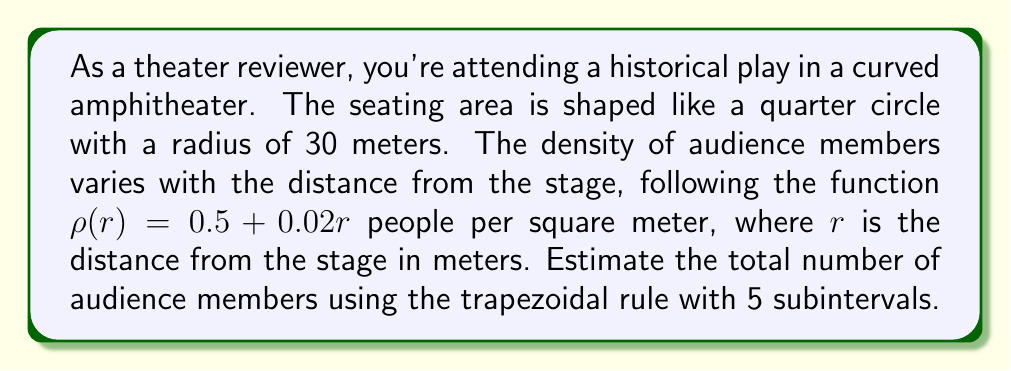Provide a solution to this math problem. To solve this problem, we'll use numerical integration with the trapezoidal rule:

1) The area of a quarter circle is given by $A = \frac{\pi r^2}{4}$. We need to integrate the density function over this area.

2) In polar coordinates, the integral is:

   $$ N = \int_0^{30} \int_0^{\pi/2} \rho(r) \cdot r \, d\theta \, dr $$

3) Integrating with respect to $\theta$:

   $$ N = \frac{\pi}{2} \int_0^{30} (0.5 + 0.02r) \cdot r \, dr $$

4) We'll use the trapezoidal rule with 5 subintervals. The step size is $h = \frac{30}{5} = 6$.

5) The trapezoidal rule formula is:

   $$ \int_a^b f(x) dx \approx \frac{h}{2}[f(x_0) + 2f(x_1) + 2f(x_2) + ... + 2f(x_{n-1}) + f(x_n)] $$

6) We need to evaluate $f(r) = \frac{\pi}{2}(0.5 + 0.02r) \cdot r$ at $r = 0, 6, 12, 18, 24, 30$:

   $f(0) = 0$
   $f(6) = 9.42\pi$
   $f(12) = 37.68\pi$
   $f(18) = 84.78\pi$
   $f(24) = 150.72\pi$
   $f(30) = 235.5\pi$

7) Applying the trapezoidal rule:

   $$ N \approx 3 \pi [0 + 2(9.42 + 37.68 + 84.78 + 150.72) + 235.5] $$

8) Calculating:

   $$ N \approx 3 \pi (565.5) \approx 5325.7 $$

Therefore, we estimate there are approximately 5,326 audience members.
Answer: 5,326 audience members 